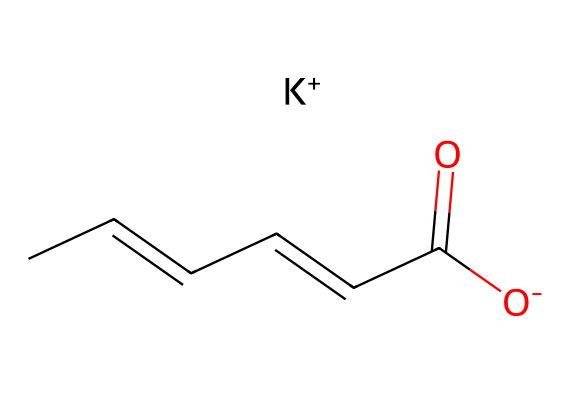What is the molecular formula of potassium sorbate? The SMILES notation can be translated to its molecular formula by identifying each atom type represented. The carbon atoms are counted (6), two oxygen atoms are present, and one potassium ion is included, leading to the formula C6H7O2K.
Answer: C6H7O2K How many carbon atoms are in potassium sorbate? From the SMILES, the notation indicates there are 6 carbon atoms as represented by 'C' before the various structural components.
Answer: 6 What functional group is present in potassium sorbate? The '-C(=O)[O-]' part of the SMILES indicates the presence of a carboxylate group, as it features a carbon atom double-bonded to oxygen and single-bonded to an oxygen that is negatively charged.
Answer: carboxylate What does the '[K+]' in the SMILES signify about potassium sorbate? The '[K+]' symbol indicates that the compound has a potassium ion which is positively charged. This reflects the compound's use as a potassium salt of sorbic acid.
Answer: potassium ion What is the main purpose of potassium sorbate in personal care products? Potassium sorbate is commonly used as a preservative to inhibit the growth of molds, yeast, and bacteria in personal care products, helping to extend their shelf life.
Answer: preservative What type of chemical is potassium sorbate categorized as? Given its properties and functional group, potassium sorbate can be classified as a preservative, specifically a food preservative that is utilized in personal care products as well.
Answer: preservative 